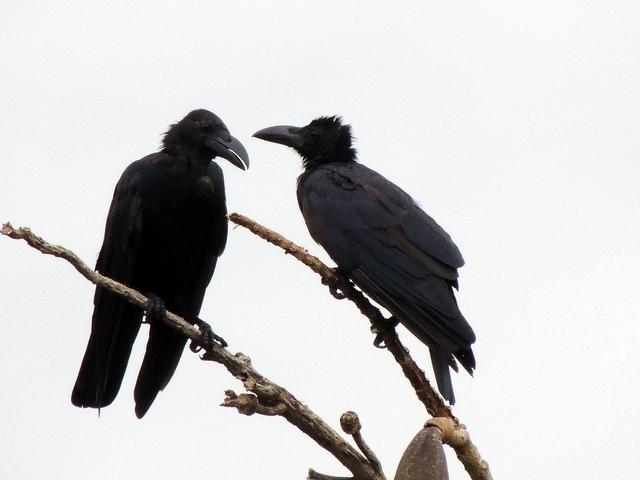What kind of birds are these?
Concise answer only. Crows. Do this animals fly?
Keep it brief. Yes. Are all the birds white?
Write a very short answer. No. 